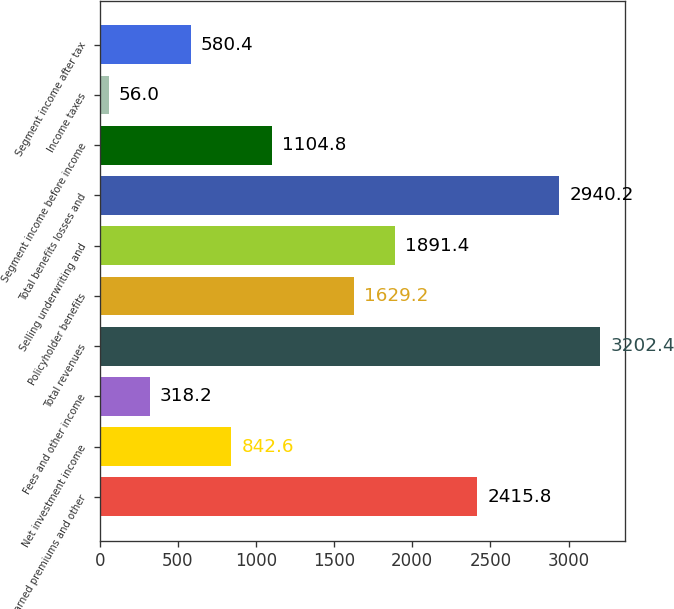Convert chart to OTSL. <chart><loc_0><loc_0><loc_500><loc_500><bar_chart><fcel>Net earned premiums and other<fcel>Net investment income<fcel>Fees and other income<fcel>Total revenues<fcel>Policyholder benefits<fcel>Selling underwriting and<fcel>Total benefits losses and<fcel>Segment income before income<fcel>Income taxes<fcel>Segment income after tax<nl><fcel>2415.8<fcel>842.6<fcel>318.2<fcel>3202.4<fcel>1629.2<fcel>1891.4<fcel>2940.2<fcel>1104.8<fcel>56<fcel>580.4<nl></chart> 